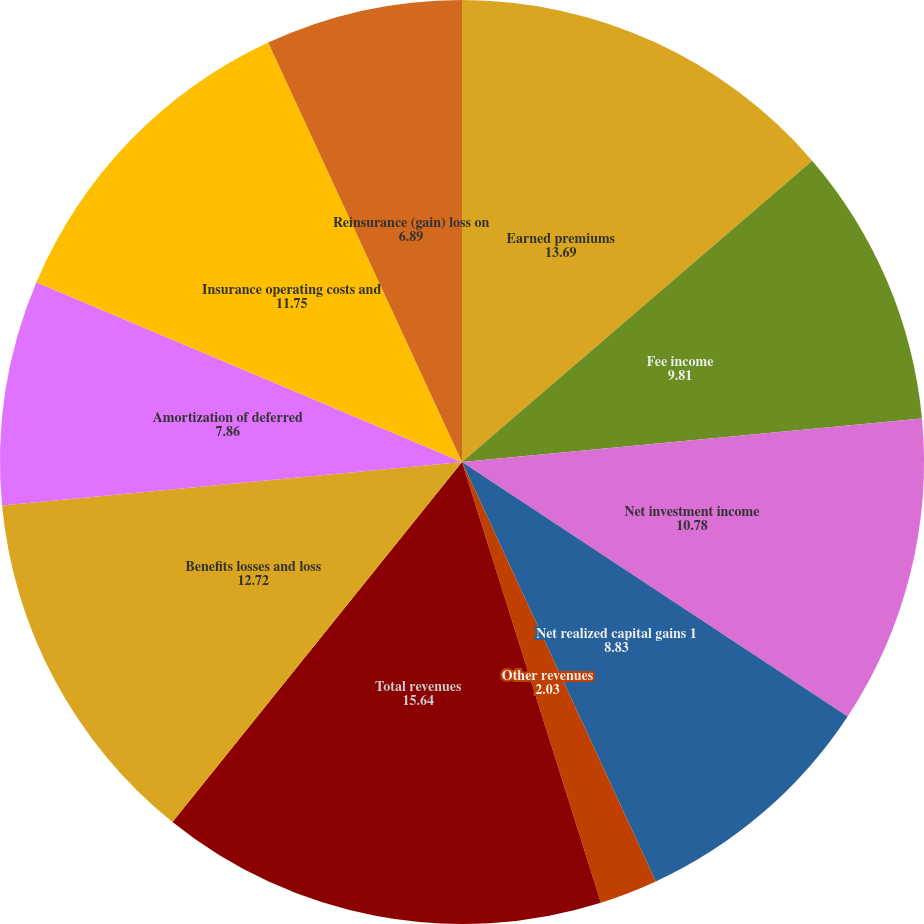Convert chart. <chart><loc_0><loc_0><loc_500><loc_500><pie_chart><fcel>Earned premiums<fcel>Fee income<fcel>Net investment income<fcel>Net realized capital gains 1<fcel>Other revenues<fcel>Total revenues<fcel>Benefits losses and loss<fcel>Amortization of deferred<fcel>Insurance operating costs and<fcel>Reinsurance (gain) loss on<nl><fcel>13.69%<fcel>9.81%<fcel>10.78%<fcel>8.83%<fcel>2.03%<fcel>15.64%<fcel>12.72%<fcel>7.86%<fcel>11.75%<fcel>6.89%<nl></chart> 